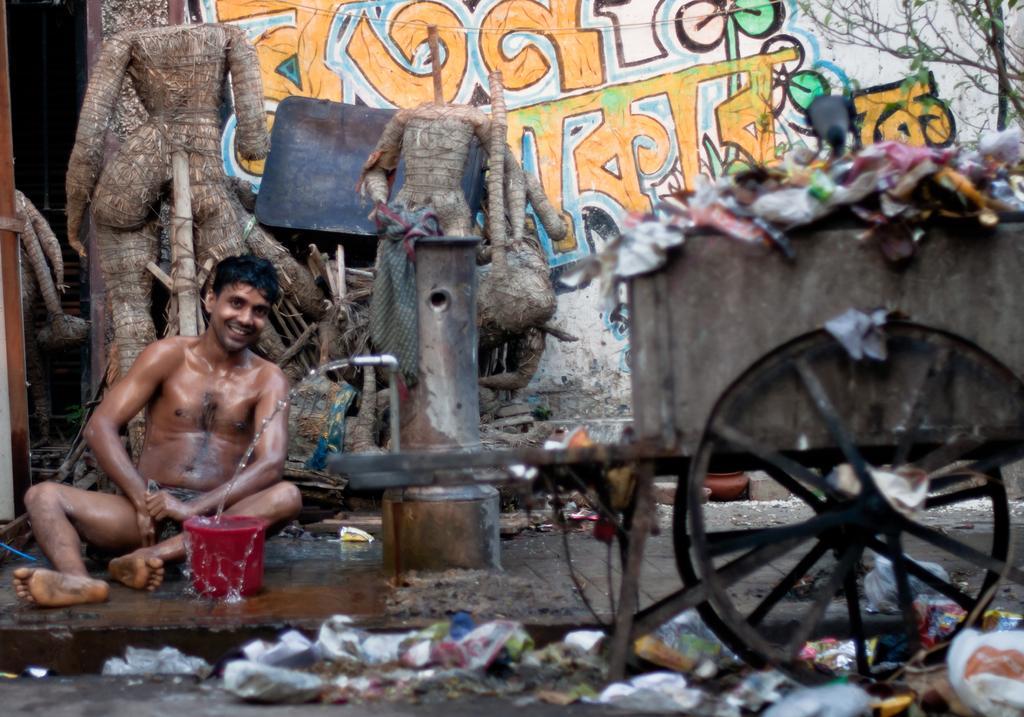In one or two sentences, can you explain what this image depicts? On the left side a man is doing bathing, this is the tap. On the right side there is a dustbin vehicle. 